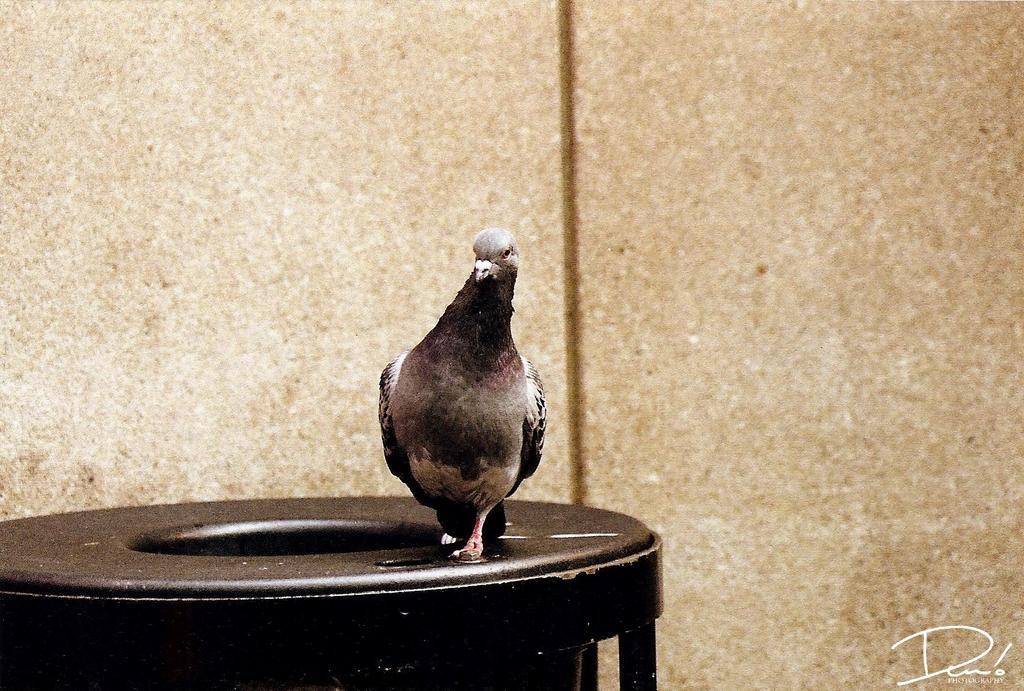In one or two sentences, can you explain what this image depicts? In this picture I can see a bird and looks like a dustbin at the bottom of the picture and I can see a wall in the background and text at the bottom right corner of the picture. 